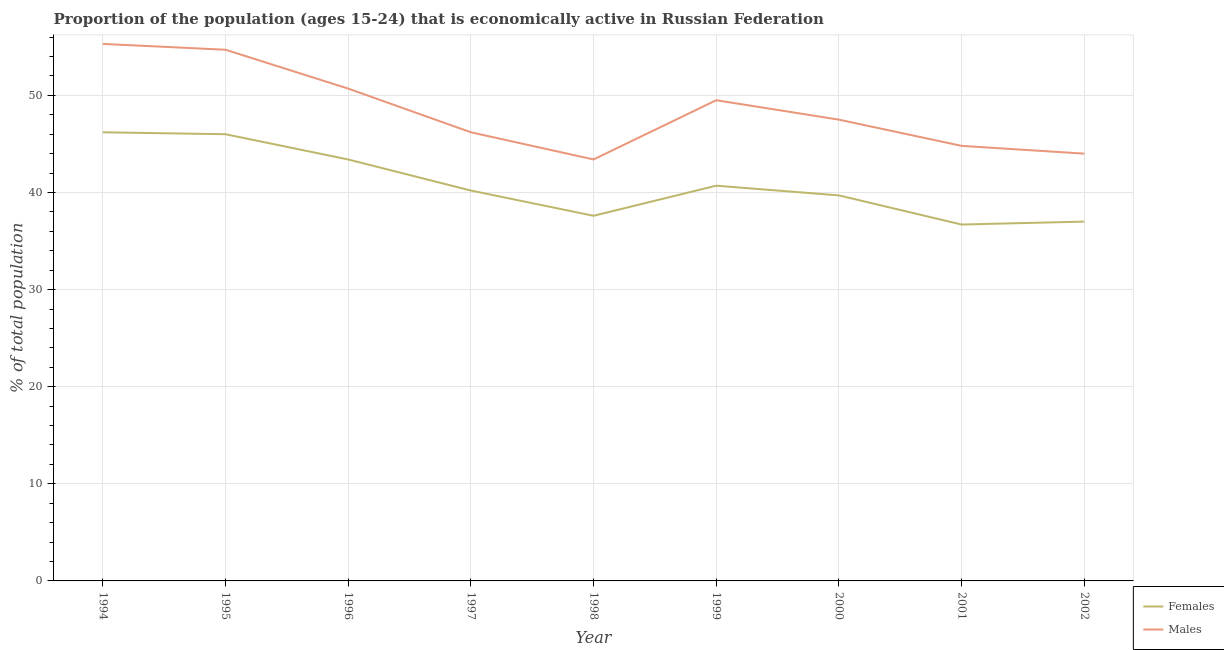How many different coloured lines are there?
Give a very brief answer. 2. What is the percentage of economically active male population in 1998?
Provide a succinct answer. 43.4. Across all years, what is the maximum percentage of economically active male population?
Make the answer very short. 55.3. Across all years, what is the minimum percentage of economically active male population?
Provide a succinct answer. 43.4. What is the total percentage of economically active female population in the graph?
Offer a terse response. 367.5. What is the difference between the percentage of economically active female population in 1998 and that in 2002?
Provide a short and direct response. 0.6. What is the difference between the percentage of economically active male population in 1996 and the percentage of economically active female population in 2000?
Your response must be concise. 11. What is the average percentage of economically active female population per year?
Your answer should be very brief. 40.83. In the year 1996, what is the difference between the percentage of economically active female population and percentage of economically active male population?
Your answer should be compact. -7.3. In how many years, is the percentage of economically active male population greater than 32 %?
Offer a terse response. 9. What is the ratio of the percentage of economically active female population in 1997 to that in 1998?
Your answer should be compact. 1.07. Is the percentage of economically active female population in 1998 less than that in 2002?
Provide a short and direct response. No. Is the difference between the percentage of economically active female population in 1996 and 2000 greater than the difference between the percentage of economically active male population in 1996 and 2000?
Give a very brief answer. Yes. What is the difference between the highest and the second highest percentage of economically active male population?
Provide a short and direct response. 0.6. What is the difference between the highest and the lowest percentage of economically active male population?
Your response must be concise. 11.9. Are the values on the major ticks of Y-axis written in scientific E-notation?
Give a very brief answer. No. Does the graph contain any zero values?
Provide a short and direct response. No. How are the legend labels stacked?
Keep it short and to the point. Vertical. What is the title of the graph?
Offer a terse response. Proportion of the population (ages 15-24) that is economically active in Russian Federation. What is the label or title of the Y-axis?
Offer a very short reply. % of total population. What is the % of total population in Females in 1994?
Ensure brevity in your answer.  46.2. What is the % of total population of Males in 1994?
Provide a short and direct response. 55.3. What is the % of total population in Males in 1995?
Your answer should be compact. 54.7. What is the % of total population in Females in 1996?
Your answer should be very brief. 43.4. What is the % of total population in Males in 1996?
Make the answer very short. 50.7. What is the % of total population of Females in 1997?
Your response must be concise. 40.2. What is the % of total population in Males in 1997?
Give a very brief answer. 46.2. What is the % of total population of Females in 1998?
Your answer should be very brief. 37.6. What is the % of total population in Males in 1998?
Your response must be concise. 43.4. What is the % of total population of Females in 1999?
Ensure brevity in your answer.  40.7. What is the % of total population of Males in 1999?
Keep it short and to the point. 49.5. What is the % of total population in Females in 2000?
Make the answer very short. 39.7. What is the % of total population in Males in 2000?
Provide a succinct answer. 47.5. What is the % of total population of Females in 2001?
Make the answer very short. 36.7. What is the % of total population of Males in 2001?
Provide a short and direct response. 44.8. What is the % of total population of Females in 2002?
Ensure brevity in your answer.  37. What is the % of total population of Males in 2002?
Make the answer very short. 44. Across all years, what is the maximum % of total population of Females?
Give a very brief answer. 46.2. Across all years, what is the maximum % of total population in Males?
Offer a very short reply. 55.3. Across all years, what is the minimum % of total population in Females?
Ensure brevity in your answer.  36.7. Across all years, what is the minimum % of total population in Males?
Ensure brevity in your answer.  43.4. What is the total % of total population in Females in the graph?
Keep it short and to the point. 367.5. What is the total % of total population in Males in the graph?
Keep it short and to the point. 436.1. What is the difference between the % of total population of Females in 1994 and that in 1995?
Give a very brief answer. 0.2. What is the difference between the % of total population in Males in 1994 and that in 1995?
Keep it short and to the point. 0.6. What is the difference between the % of total population of Females in 1994 and that in 1997?
Your response must be concise. 6. What is the difference between the % of total population of Males in 1994 and that in 1997?
Offer a terse response. 9.1. What is the difference between the % of total population of Females in 1994 and that in 1999?
Offer a very short reply. 5.5. What is the difference between the % of total population of Males in 1994 and that in 2001?
Offer a terse response. 10.5. What is the difference between the % of total population in Females in 1995 and that in 1996?
Give a very brief answer. 2.6. What is the difference between the % of total population of Males in 1995 and that in 1996?
Your answer should be very brief. 4. What is the difference between the % of total population of Females in 1995 and that in 1997?
Offer a terse response. 5.8. What is the difference between the % of total population of Females in 1995 and that in 1998?
Ensure brevity in your answer.  8.4. What is the difference between the % of total population of Females in 1995 and that in 1999?
Offer a terse response. 5.3. What is the difference between the % of total population of Males in 1995 and that in 1999?
Make the answer very short. 5.2. What is the difference between the % of total population of Females in 1995 and that in 2000?
Give a very brief answer. 6.3. What is the difference between the % of total population of Males in 1995 and that in 2000?
Your answer should be very brief. 7.2. What is the difference between the % of total population in Females in 1995 and that in 2001?
Keep it short and to the point. 9.3. What is the difference between the % of total population of Females in 1995 and that in 2002?
Your answer should be very brief. 9. What is the difference between the % of total population in Females in 1996 and that in 1997?
Keep it short and to the point. 3.2. What is the difference between the % of total population of Males in 1996 and that in 1997?
Ensure brevity in your answer.  4.5. What is the difference between the % of total population of Males in 1996 and that in 1998?
Offer a terse response. 7.3. What is the difference between the % of total population of Males in 1996 and that in 1999?
Give a very brief answer. 1.2. What is the difference between the % of total population of Females in 1996 and that in 2000?
Ensure brevity in your answer.  3.7. What is the difference between the % of total population in Females in 1996 and that in 2002?
Offer a very short reply. 6.4. What is the difference between the % of total population of Males in 1996 and that in 2002?
Your response must be concise. 6.7. What is the difference between the % of total population in Females in 1997 and that in 1999?
Offer a terse response. -0.5. What is the difference between the % of total population in Males in 1997 and that in 1999?
Offer a terse response. -3.3. What is the difference between the % of total population of Females in 1997 and that in 2000?
Ensure brevity in your answer.  0.5. What is the difference between the % of total population in Males in 1997 and that in 2000?
Give a very brief answer. -1.3. What is the difference between the % of total population in Females in 1997 and that in 2001?
Your answer should be very brief. 3.5. What is the difference between the % of total population in Females in 1998 and that in 1999?
Your answer should be compact. -3.1. What is the difference between the % of total population in Males in 1998 and that in 1999?
Your answer should be very brief. -6.1. What is the difference between the % of total population of Females in 1998 and that in 2000?
Give a very brief answer. -2.1. What is the difference between the % of total population of Males in 1998 and that in 2000?
Your answer should be compact. -4.1. What is the difference between the % of total population in Females in 1998 and that in 2001?
Give a very brief answer. 0.9. What is the difference between the % of total population in Males in 1998 and that in 2001?
Ensure brevity in your answer.  -1.4. What is the difference between the % of total population of Females in 1999 and that in 2000?
Your answer should be compact. 1. What is the difference between the % of total population in Females in 1999 and that in 2001?
Keep it short and to the point. 4. What is the difference between the % of total population in Males in 1999 and that in 2001?
Ensure brevity in your answer.  4.7. What is the difference between the % of total population of Females in 1999 and that in 2002?
Offer a terse response. 3.7. What is the difference between the % of total population of Females in 2001 and that in 2002?
Give a very brief answer. -0.3. What is the difference between the % of total population of Males in 2001 and that in 2002?
Your answer should be compact. 0.8. What is the difference between the % of total population in Females in 1994 and the % of total population in Males in 1996?
Make the answer very short. -4.5. What is the difference between the % of total population of Females in 1994 and the % of total population of Males in 1997?
Your answer should be very brief. 0. What is the difference between the % of total population of Females in 1994 and the % of total population of Males in 1998?
Offer a very short reply. 2.8. What is the difference between the % of total population in Females in 1994 and the % of total population in Males in 2000?
Your answer should be very brief. -1.3. What is the difference between the % of total population of Females in 1994 and the % of total population of Males in 2001?
Your answer should be compact. 1.4. What is the difference between the % of total population in Females in 1995 and the % of total population in Males in 1996?
Ensure brevity in your answer.  -4.7. What is the difference between the % of total population of Females in 1995 and the % of total population of Males in 1997?
Provide a short and direct response. -0.2. What is the difference between the % of total population of Females in 1995 and the % of total population of Males in 1999?
Your answer should be very brief. -3.5. What is the difference between the % of total population of Females in 1996 and the % of total population of Males in 2000?
Provide a short and direct response. -4.1. What is the difference between the % of total population in Females in 1996 and the % of total population in Males in 2001?
Ensure brevity in your answer.  -1.4. What is the difference between the % of total population in Females in 1997 and the % of total population in Males in 1998?
Provide a succinct answer. -3.2. What is the difference between the % of total population of Females in 1998 and the % of total population of Males in 1999?
Make the answer very short. -11.9. What is the difference between the % of total population of Females in 1998 and the % of total population of Males in 2000?
Offer a terse response. -9.9. What is the difference between the % of total population in Females in 1998 and the % of total population in Males in 2001?
Provide a succinct answer. -7.2. What is the difference between the % of total population of Females in 1999 and the % of total population of Males in 2001?
Provide a succinct answer. -4.1. What is the difference between the % of total population of Females in 1999 and the % of total population of Males in 2002?
Your response must be concise. -3.3. What is the difference between the % of total population in Females in 2001 and the % of total population in Males in 2002?
Provide a succinct answer. -7.3. What is the average % of total population of Females per year?
Provide a succinct answer. 40.83. What is the average % of total population in Males per year?
Offer a very short reply. 48.46. In the year 1994, what is the difference between the % of total population in Females and % of total population in Males?
Offer a very short reply. -9.1. In the year 1996, what is the difference between the % of total population of Females and % of total population of Males?
Ensure brevity in your answer.  -7.3. In the year 1997, what is the difference between the % of total population of Females and % of total population of Males?
Provide a short and direct response. -6. In the year 1999, what is the difference between the % of total population in Females and % of total population in Males?
Provide a short and direct response. -8.8. In the year 2000, what is the difference between the % of total population in Females and % of total population in Males?
Your response must be concise. -7.8. What is the ratio of the % of total population of Females in 1994 to that in 1995?
Give a very brief answer. 1. What is the ratio of the % of total population of Females in 1994 to that in 1996?
Offer a terse response. 1.06. What is the ratio of the % of total population in Males in 1994 to that in 1996?
Provide a succinct answer. 1.09. What is the ratio of the % of total population of Females in 1994 to that in 1997?
Ensure brevity in your answer.  1.15. What is the ratio of the % of total population in Males in 1994 to that in 1997?
Make the answer very short. 1.2. What is the ratio of the % of total population of Females in 1994 to that in 1998?
Offer a terse response. 1.23. What is the ratio of the % of total population of Males in 1994 to that in 1998?
Give a very brief answer. 1.27. What is the ratio of the % of total population of Females in 1994 to that in 1999?
Offer a terse response. 1.14. What is the ratio of the % of total population in Males in 1994 to that in 1999?
Your answer should be compact. 1.12. What is the ratio of the % of total population in Females in 1994 to that in 2000?
Provide a succinct answer. 1.16. What is the ratio of the % of total population of Males in 1994 to that in 2000?
Your answer should be very brief. 1.16. What is the ratio of the % of total population in Females in 1994 to that in 2001?
Make the answer very short. 1.26. What is the ratio of the % of total population in Males in 1994 to that in 2001?
Make the answer very short. 1.23. What is the ratio of the % of total population of Females in 1994 to that in 2002?
Make the answer very short. 1.25. What is the ratio of the % of total population in Males in 1994 to that in 2002?
Give a very brief answer. 1.26. What is the ratio of the % of total population in Females in 1995 to that in 1996?
Keep it short and to the point. 1.06. What is the ratio of the % of total population of Males in 1995 to that in 1996?
Your answer should be very brief. 1.08. What is the ratio of the % of total population in Females in 1995 to that in 1997?
Give a very brief answer. 1.14. What is the ratio of the % of total population of Males in 1995 to that in 1997?
Offer a very short reply. 1.18. What is the ratio of the % of total population of Females in 1995 to that in 1998?
Give a very brief answer. 1.22. What is the ratio of the % of total population of Males in 1995 to that in 1998?
Provide a short and direct response. 1.26. What is the ratio of the % of total population of Females in 1995 to that in 1999?
Keep it short and to the point. 1.13. What is the ratio of the % of total population in Males in 1995 to that in 1999?
Offer a very short reply. 1.11. What is the ratio of the % of total population in Females in 1995 to that in 2000?
Provide a succinct answer. 1.16. What is the ratio of the % of total population of Males in 1995 to that in 2000?
Provide a short and direct response. 1.15. What is the ratio of the % of total population in Females in 1995 to that in 2001?
Provide a succinct answer. 1.25. What is the ratio of the % of total population of Males in 1995 to that in 2001?
Your answer should be compact. 1.22. What is the ratio of the % of total population of Females in 1995 to that in 2002?
Offer a terse response. 1.24. What is the ratio of the % of total population of Males in 1995 to that in 2002?
Give a very brief answer. 1.24. What is the ratio of the % of total population of Females in 1996 to that in 1997?
Your response must be concise. 1.08. What is the ratio of the % of total population in Males in 1996 to that in 1997?
Your response must be concise. 1.1. What is the ratio of the % of total population of Females in 1996 to that in 1998?
Give a very brief answer. 1.15. What is the ratio of the % of total population of Males in 1996 to that in 1998?
Give a very brief answer. 1.17. What is the ratio of the % of total population of Females in 1996 to that in 1999?
Your answer should be very brief. 1.07. What is the ratio of the % of total population of Males in 1996 to that in 1999?
Offer a very short reply. 1.02. What is the ratio of the % of total population in Females in 1996 to that in 2000?
Keep it short and to the point. 1.09. What is the ratio of the % of total population of Males in 1996 to that in 2000?
Your answer should be compact. 1.07. What is the ratio of the % of total population in Females in 1996 to that in 2001?
Offer a very short reply. 1.18. What is the ratio of the % of total population in Males in 1996 to that in 2001?
Your response must be concise. 1.13. What is the ratio of the % of total population of Females in 1996 to that in 2002?
Give a very brief answer. 1.17. What is the ratio of the % of total population in Males in 1996 to that in 2002?
Your answer should be compact. 1.15. What is the ratio of the % of total population in Females in 1997 to that in 1998?
Your response must be concise. 1.07. What is the ratio of the % of total population in Males in 1997 to that in 1998?
Provide a succinct answer. 1.06. What is the ratio of the % of total population in Females in 1997 to that in 1999?
Provide a succinct answer. 0.99. What is the ratio of the % of total population in Males in 1997 to that in 1999?
Your answer should be compact. 0.93. What is the ratio of the % of total population of Females in 1997 to that in 2000?
Your answer should be very brief. 1.01. What is the ratio of the % of total population in Males in 1997 to that in 2000?
Provide a succinct answer. 0.97. What is the ratio of the % of total population of Females in 1997 to that in 2001?
Offer a terse response. 1.1. What is the ratio of the % of total population of Males in 1997 to that in 2001?
Your answer should be very brief. 1.03. What is the ratio of the % of total population of Females in 1997 to that in 2002?
Provide a succinct answer. 1.09. What is the ratio of the % of total population in Males in 1997 to that in 2002?
Ensure brevity in your answer.  1.05. What is the ratio of the % of total population in Females in 1998 to that in 1999?
Make the answer very short. 0.92. What is the ratio of the % of total population in Males in 1998 to that in 1999?
Your response must be concise. 0.88. What is the ratio of the % of total population in Females in 1998 to that in 2000?
Provide a short and direct response. 0.95. What is the ratio of the % of total population in Males in 1998 to that in 2000?
Ensure brevity in your answer.  0.91. What is the ratio of the % of total population of Females in 1998 to that in 2001?
Your response must be concise. 1.02. What is the ratio of the % of total population of Males in 1998 to that in 2001?
Offer a very short reply. 0.97. What is the ratio of the % of total population in Females in 1998 to that in 2002?
Offer a very short reply. 1.02. What is the ratio of the % of total population of Males in 1998 to that in 2002?
Give a very brief answer. 0.99. What is the ratio of the % of total population of Females in 1999 to that in 2000?
Provide a short and direct response. 1.03. What is the ratio of the % of total population of Males in 1999 to that in 2000?
Ensure brevity in your answer.  1.04. What is the ratio of the % of total population in Females in 1999 to that in 2001?
Your answer should be very brief. 1.11. What is the ratio of the % of total population in Males in 1999 to that in 2001?
Your response must be concise. 1.1. What is the ratio of the % of total population of Females in 1999 to that in 2002?
Make the answer very short. 1.1. What is the ratio of the % of total population of Males in 1999 to that in 2002?
Ensure brevity in your answer.  1.12. What is the ratio of the % of total population in Females in 2000 to that in 2001?
Make the answer very short. 1.08. What is the ratio of the % of total population in Males in 2000 to that in 2001?
Offer a terse response. 1.06. What is the ratio of the % of total population of Females in 2000 to that in 2002?
Your answer should be compact. 1.07. What is the ratio of the % of total population in Males in 2000 to that in 2002?
Your response must be concise. 1.08. What is the ratio of the % of total population in Females in 2001 to that in 2002?
Your answer should be very brief. 0.99. What is the ratio of the % of total population of Males in 2001 to that in 2002?
Keep it short and to the point. 1.02. What is the difference between the highest and the second highest % of total population of Males?
Make the answer very short. 0.6. What is the difference between the highest and the lowest % of total population of Females?
Provide a short and direct response. 9.5. 